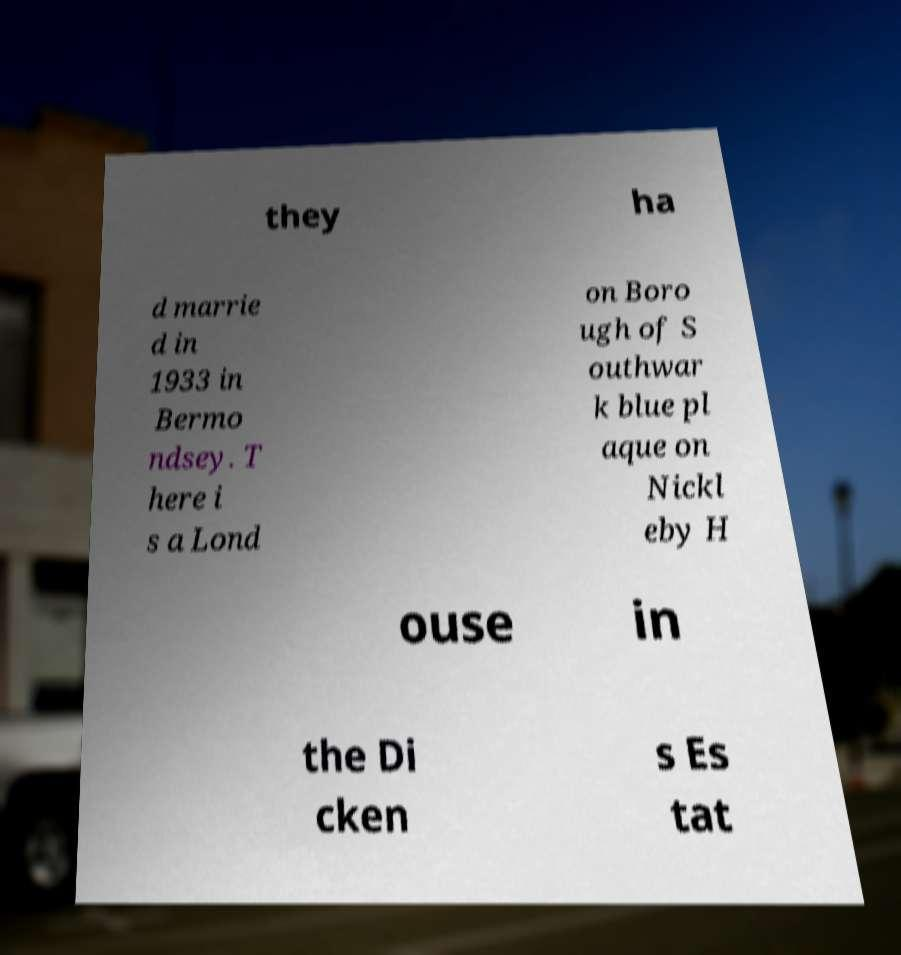Please identify and transcribe the text found in this image. they ha d marrie d in 1933 in Bermo ndsey. T here i s a Lond on Boro ugh of S outhwar k blue pl aque on Nickl eby H ouse in the Di cken s Es tat 